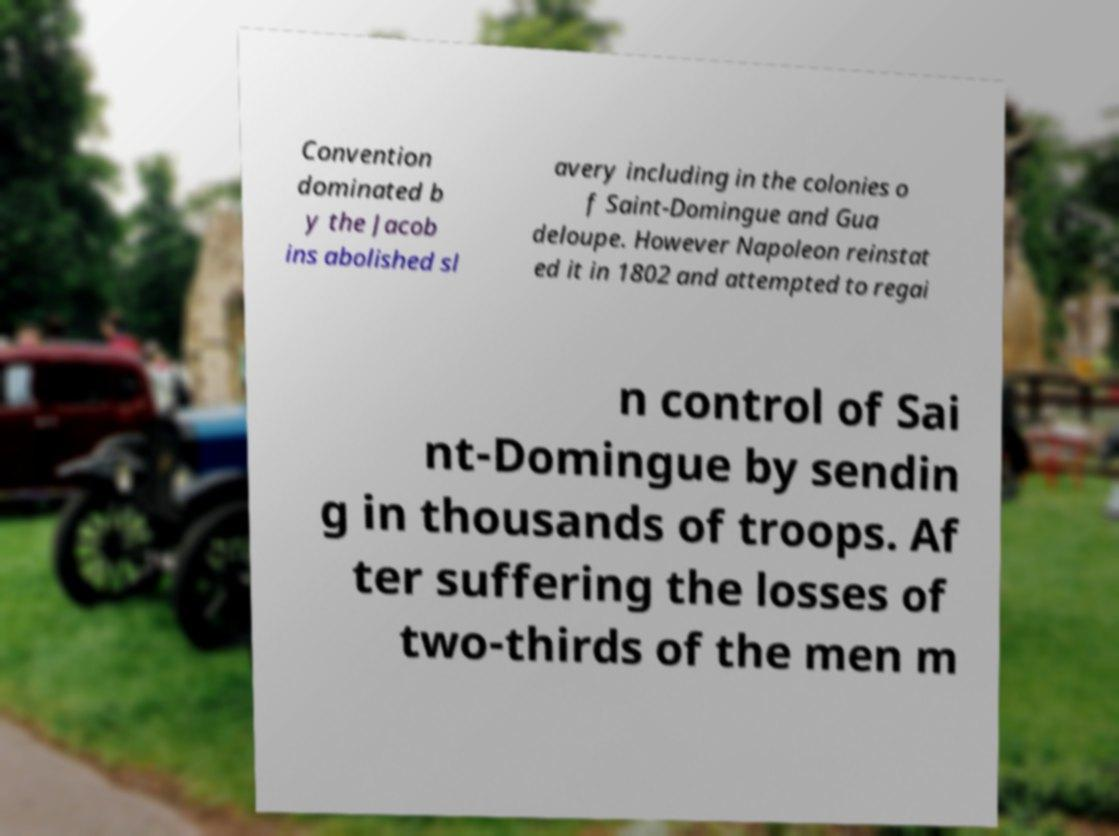There's text embedded in this image that I need extracted. Can you transcribe it verbatim? Convention dominated b y the Jacob ins abolished sl avery including in the colonies o f Saint-Domingue and Gua deloupe. However Napoleon reinstat ed it in 1802 and attempted to regai n control of Sai nt-Domingue by sendin g in thousands of troops. Af ter suffering the losses of two-thirds of the men m 